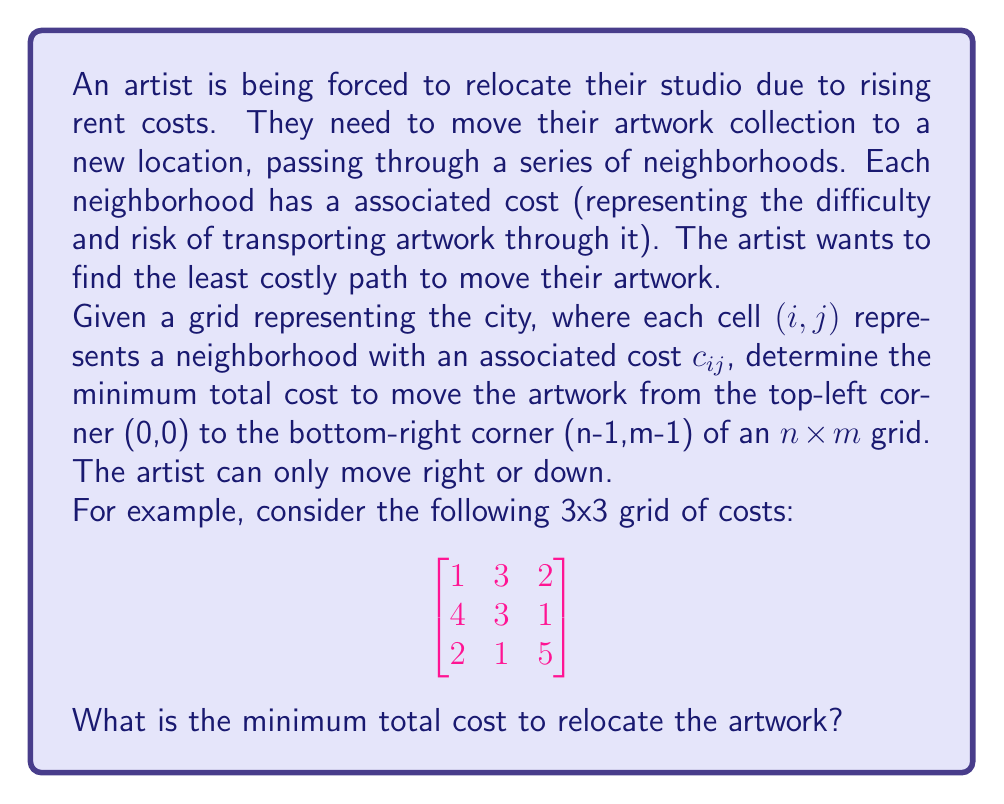What is the answer to this math problem? To solve this problem, we can use dynamic programming. Let's define $dp[i][j]$ as the minimum cost to reach cell $(i,j)$ from $(0,0)$.

The recurrence relation for this problem is:

$$dp[i][j] = c_{ij} + \min(dp[i-1][j], dp[i][j-1])$$

Where $c_{ij}$ is the cost of the current cell.

Base cases:
1. $dp[0][0] = c_{00}$
2. For the first row: $dp[0][j] = dp[0][j-1] + c_{0j}$
3. For the first column: $dp[i][0] = dp[i-1][0] + c_{i0}$

Let's solve the given example step by step:

1. Initialize the DP table:

$$
\begin{bmatrix}
1 & - & - \\
- & - & - \\
- & - & -
\end{bmatrix}
$$

2. Fill the first row:

$$
\begin{bmatrix}
1 & 4 & 6 \\
- & - & - \\
- & - & -
\end{bmatrix}
$$

3. Fill the first column:

$$
\begin{bmatrix}
1 & 4 & 6 \\
5 & - & - \\
7 & - & -
\end{bmatrix}
$$

4. Fill the rest of the table using the recurrence relation:

$$
\begin{bmatrix}
1 & 4 & 6 \\
5 & 7 & 7 \\
7 & 8 & 12
\end{bmatrix}
$$

The minimum total cost is the value in the bottom-right cell, which is 12.

The optimal path can be reconstructed by backtracking from the bottom-right cell, always choosing the direction (up or left) with the smaller value. In this case, the optimal path is:

$$(0,0) \rightarrow (0,1) \rightarrow (1,1) \rightarrow (1,2) \rightarrow (2,2)$$

This path represents: Right, Down, Right, Down.
Answer: The minimum total cost to relocate the artwork is 12. 